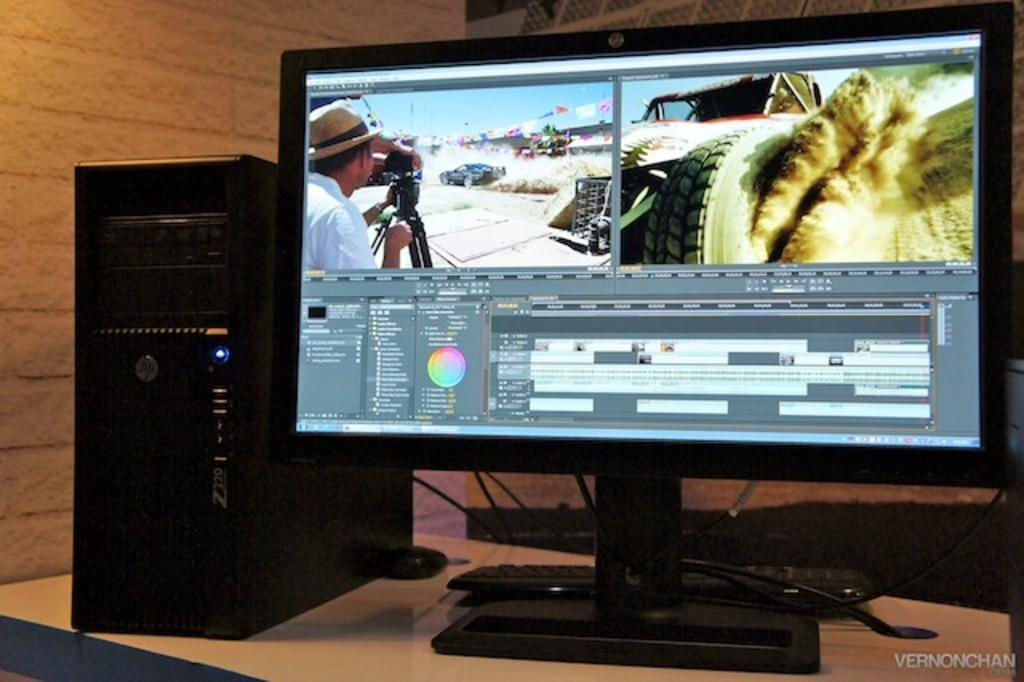<image>
Provide a brief description of the given image. and HP computer sits near a monitor showing a split screen of cars 